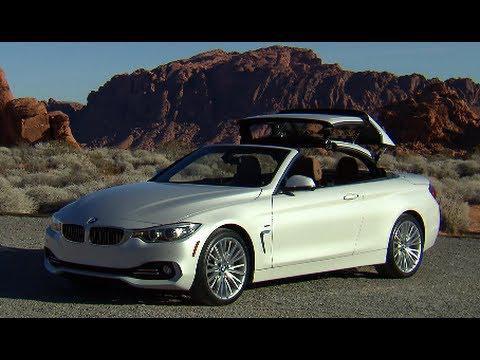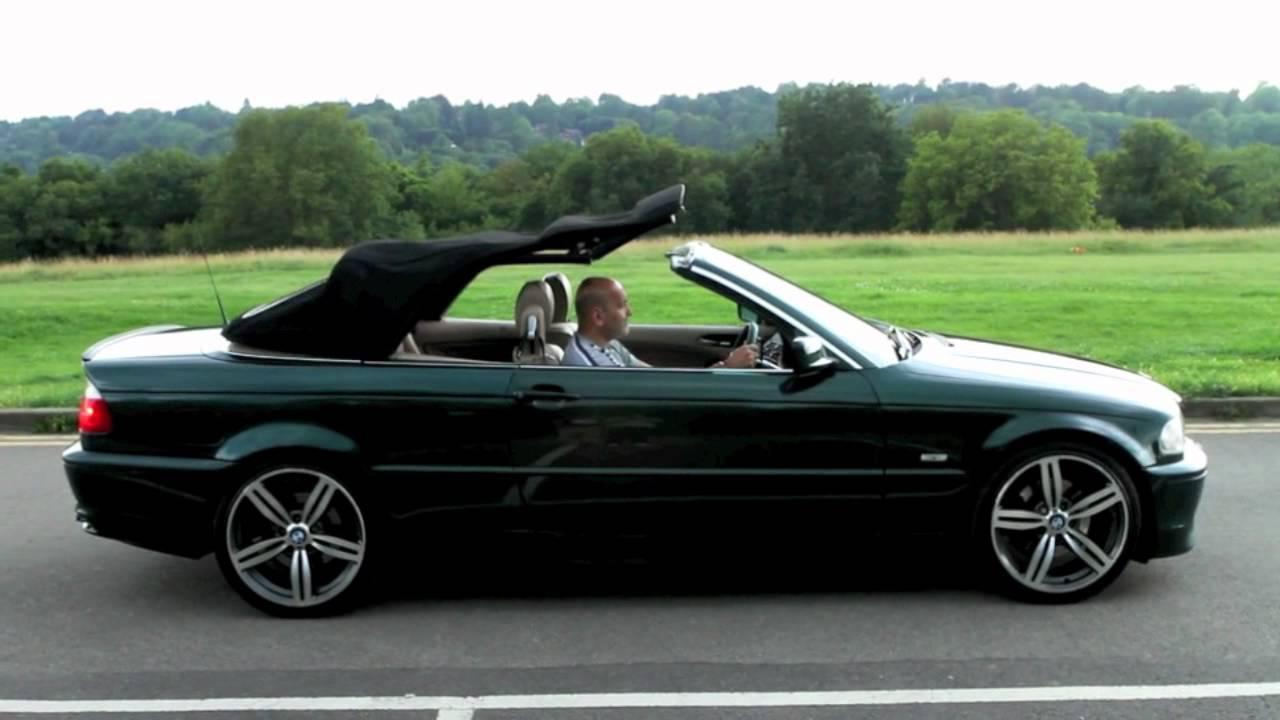The first image is the image on the left, the second image is the image on the right. Considering the images on both sides, is "Each image shows the entire length of a sports car with a convertible top that is in the act of being lowered." valid? Answer yes or no. Yes. The first image is the image on the left, the second image is the image on the right. Given the left and right images, does the statement "An image shows brown rocky peaks behind a white convertible with its top partly extended." hold true? Answer yes or no. Yes. 